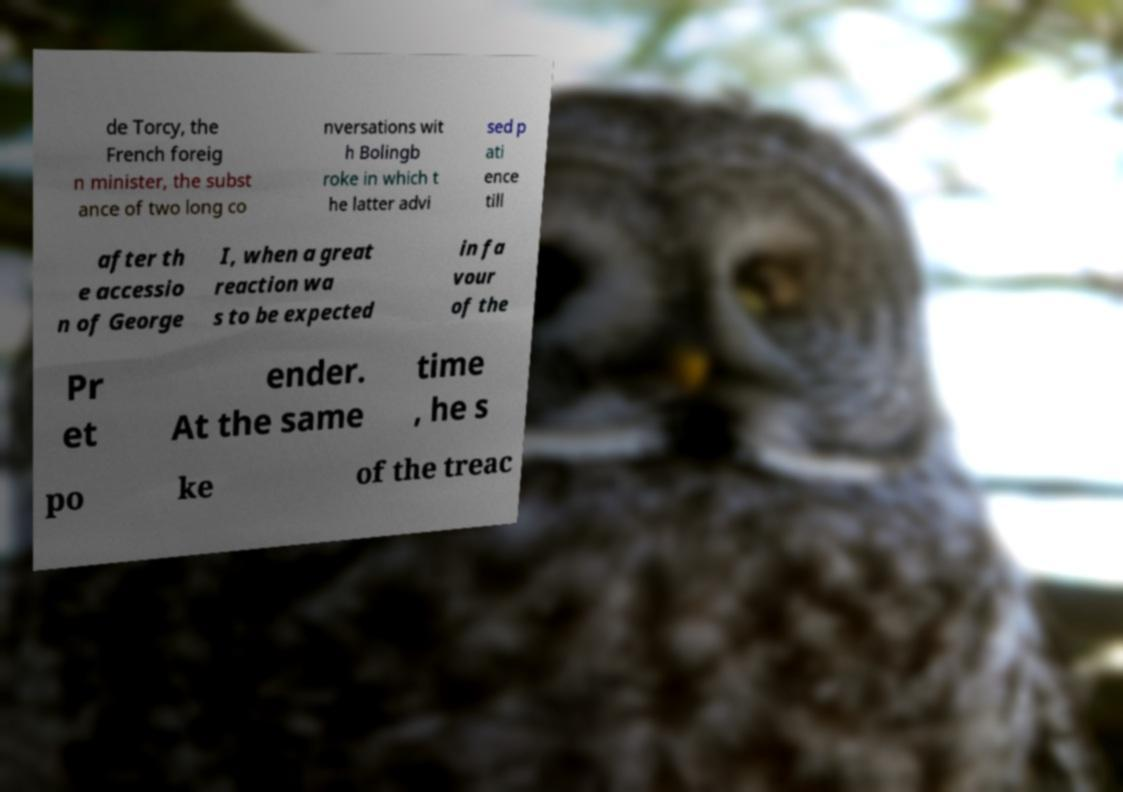What messages or text are displayed in this image? I need them in a readable, typed format. de Torcy, the French foreig n minister, the subst ance of two long co nversations wit h Bolingb roke in which t he latter advi sed p ati ence till after th e accessio n of George I, when a great reaction wa s to be expected in fa vour of the Pr et ender. At the same time , he s po ke of the treac 